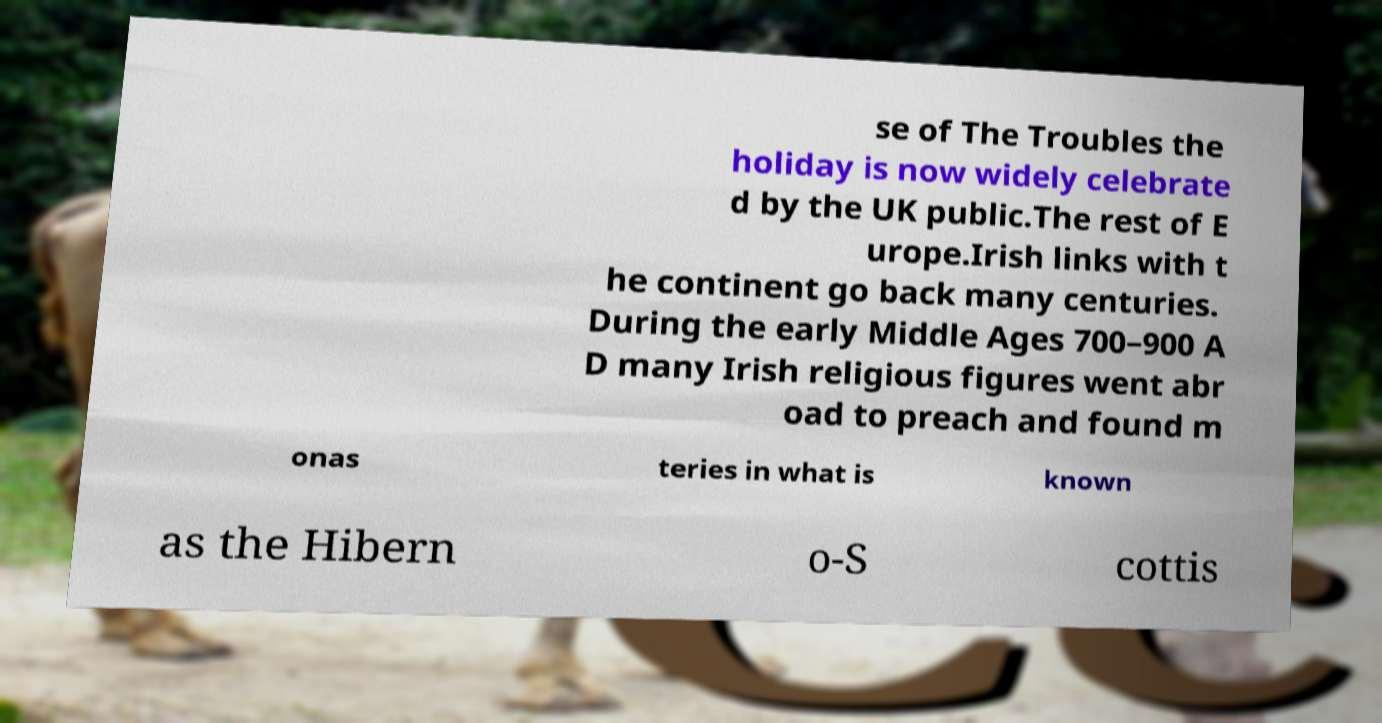Can you accurately transcribe the text from the provided image for me? se of The Troubles the holiday is now widely celebrate d by the UK public.The rest of E urope.Irish links with t he continent go back many centuries. During the early Middle Ages 700–900 A D many Irish religious figures went abr oad to preach and found m onas teries in what is known as the Hibern o-S cottis 